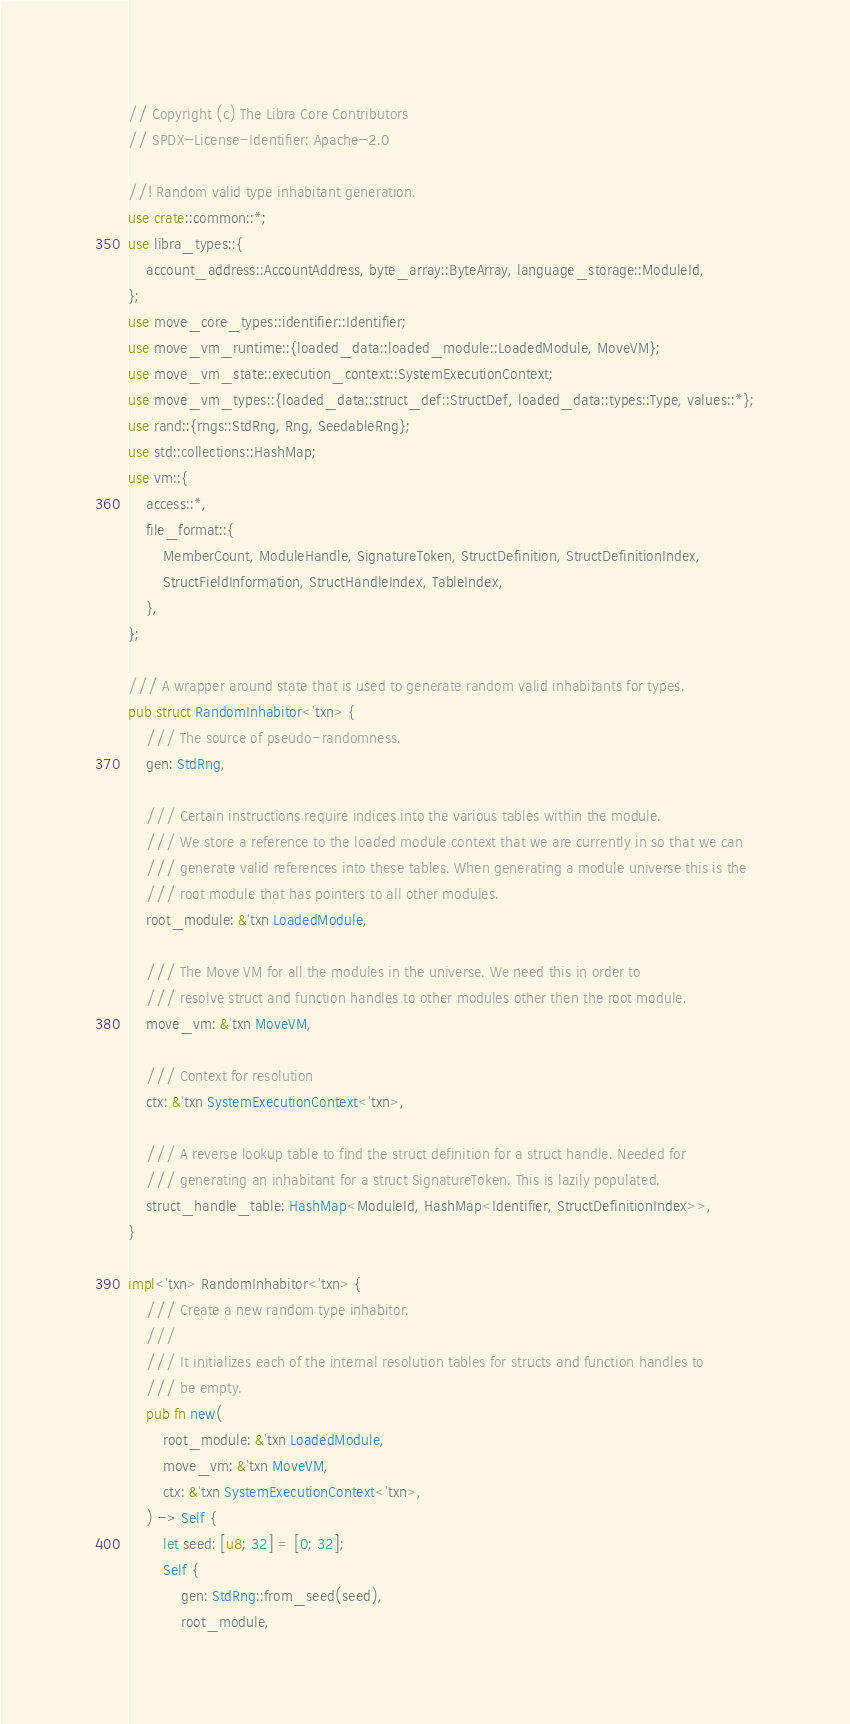<code> <loc_0><loc_0><loc_500><loc_500><_Rust_>// Copyright (c) The Libra Core Contributors
// SPDX-License-Identifier: Apache-2.0

//! Random valid type inhabitant generation.
use crate::common::*;
use libra_types::{
    account_address::AccountAddress, byte_array::ByteArray, language_storage::ModuleId,
};
use move_core_types::identifier::Identifier;
use move_vm_runtime::{loaded_data::loaded_module::LoadedModule, MoveVM};
use move_vm_state::execution_context::SystemExecutionContext;
use move_vm_types::{loaded_data::struct_def::StructDef, loaded_data::types::Type, values::*};
use rand::{rngs::StdRng, Rng, SeedableRng};
use std::collections::HashMap;
use vm::{
    access::*,
    file_format::{
        MemberCount, ModuleHandle, SignatureToken, StructDefinition, StructDefinitionIndex,
        StructFieldInformation, StructHandleIndex, TableIndex,
    },
};

/// A wrapper around state that is used to generate random valid inhabitants for types.
pub struct RandomInhabitor<'txn> {
    /// The source of pseudo-randomness.
    gen: StdRng,

    /// Certain instructions require indices into the various tables within the module.
    /// We store a reference to the loaded module context that we are currently in so that we can
    /// generate valid references into these tables. When generating a module universe this is the
    /// root module that has pointers to all other modules.
    root_module: &'txn LoadedModule,

    /// The Move VM for all the modules in the universe. We need this in order to
    /// resolve struct and function handles to other modules other then the root module.
    move_vm: &'txn MoveVM,

    /// Context for resolution
    ctx: &'txn SystemExecutionContext<'txn>,

    /// A reverse lookup table to find the struct definition for a struct handle. Needed for
    /// generating an inhabitant for a struct SignatureToken. This is lazily populated.
    struct_handle_table: HashMap<ModuleId, HashMap<Identifier, StructDefinitionIndex>>,
}

impl<'txn> RandomInhabitor<'txn> {
    /// Create a new random type inhabitor.
    ///
    /// It initializes each of the internal resolution tables for structs and function handles to
    /// be empty.
    pub fn new(
        root_module: &'txn LoadedModule,
        move_vm: &'txn MoveVM,
        ctx: &'txn SystemExecutionContext<'txn>,
    ) -> Self {
        let seed: [u8; 32] = [0; 32];
        Self {
            gen: StdRng::from_seed(seed),
            root_module,</code> 